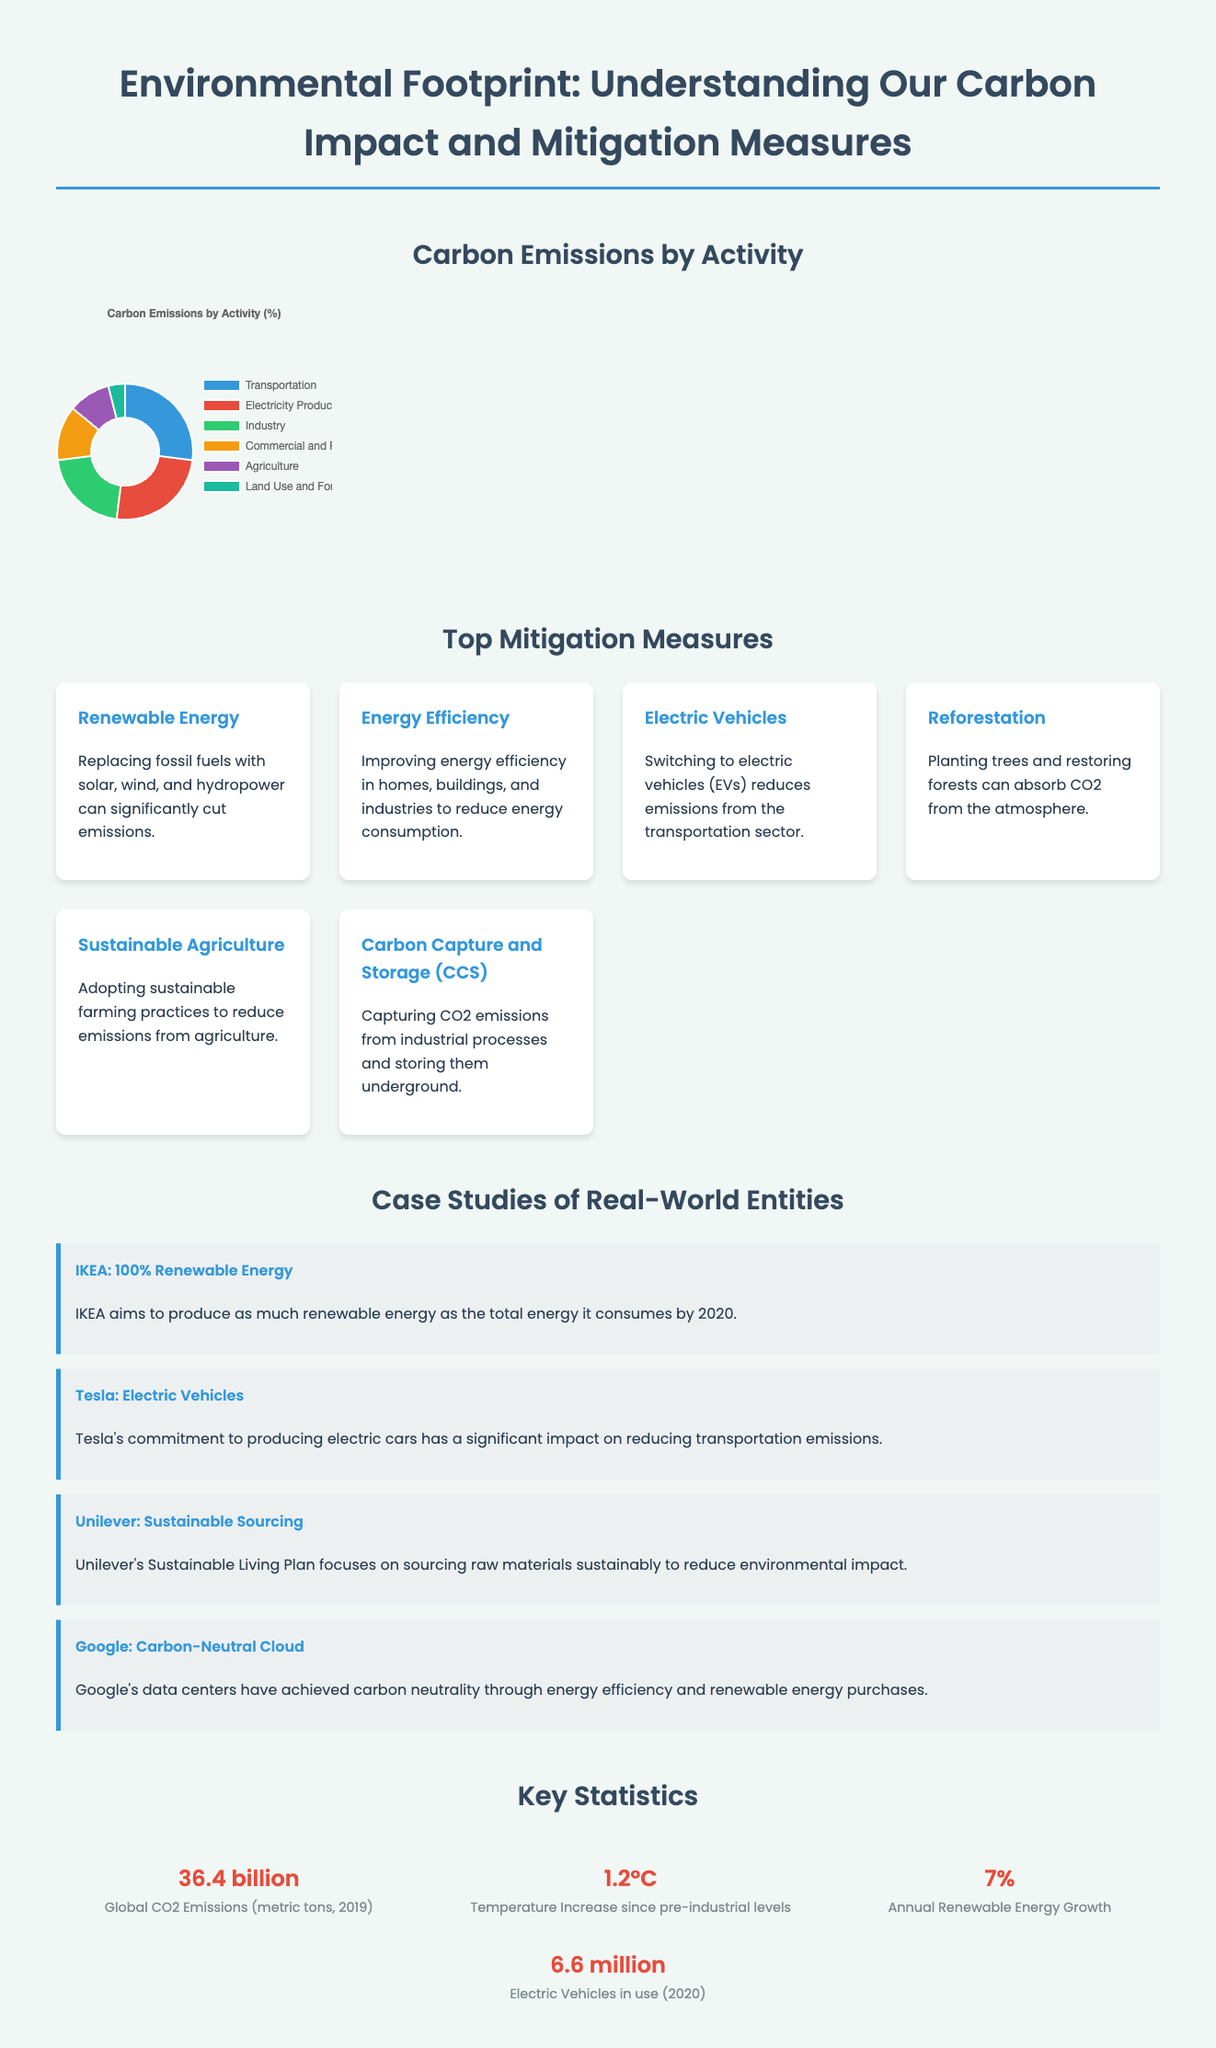What are the top two sources of carbon emissions? The top two sources of carbon emissions are shown as categories in the emissions chart: Transportation and Electricity Production.
Answer: Transportation, Electricity Production What is the total global CO2 emissions in metric tons for 2019? The total global CO2 emissions for 2019 is mentioned in the key statistics section of the document.
Answer: 36.4 billion Which company aims to use 100% renewable energy? The case study section mentions IKEA's goal of producing as much renewable energy as it consumes by 2020.
Answer: IKEA What percentage of carbon emissions comes from Agriculture? The emissions chart indicates that Agriculture accounts for a specific percentage of total carbon emissions.
Answer: 10% What is the annual growth rate of renewable energy? The document provides a statistic regarding the annual renewable energy growth rate.
Answer: 7% How does Tesla contribute to reducing transportation emissions? The document includes a case study highlighting Tesla’s impact on transportation through electric vehicle production.
Answer: Electric Vehicles What was the temperature increase since pre-industrial levels? The relevant statistic in the document indicates the temperature increase since pre-industrial levels.
Answer: 1.2°C 